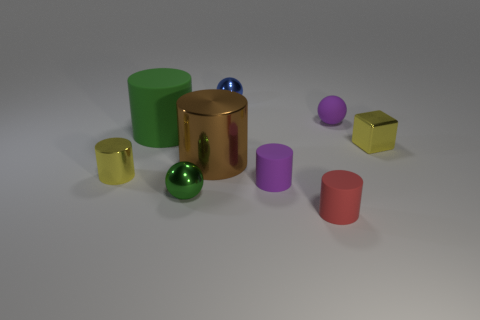Subtract 2 cylinders. How many cylinders are left? 3 Subtract all blue cylinders. Subtract all purple spheres. How many cylinders are left? 5 Subtract all blocks. How many objects are left? 8 Subtract all tiny shiny spheres. Subtract all large cylinders. How many objects are left? 5 Add 5 green shiny spheres. How many green shiny spheres are left? 6 Add 7 small blue matte things. How many small blue matte things exist? 7 Subtract 0 gray spheres. How many objects are left? 9 